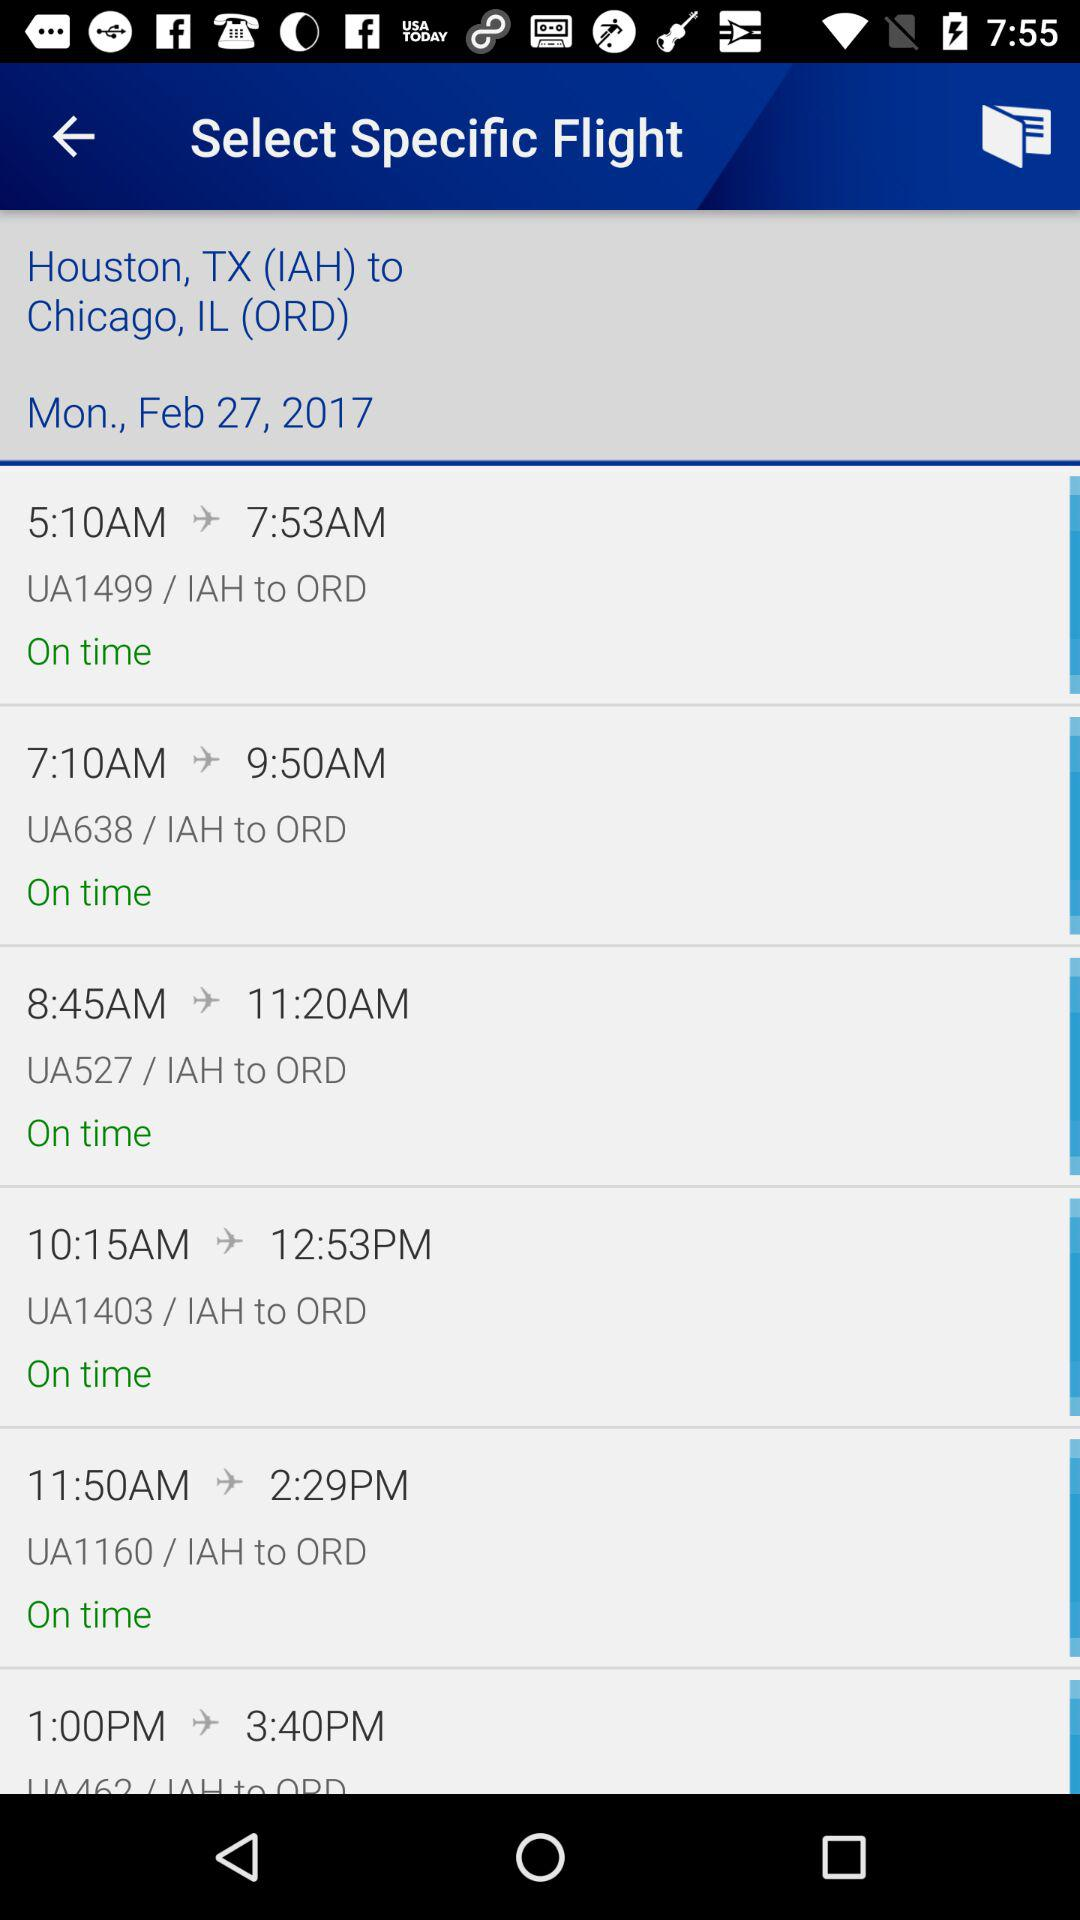From where does the flight take off? The flight takes off from Houston, TX (IAH). 